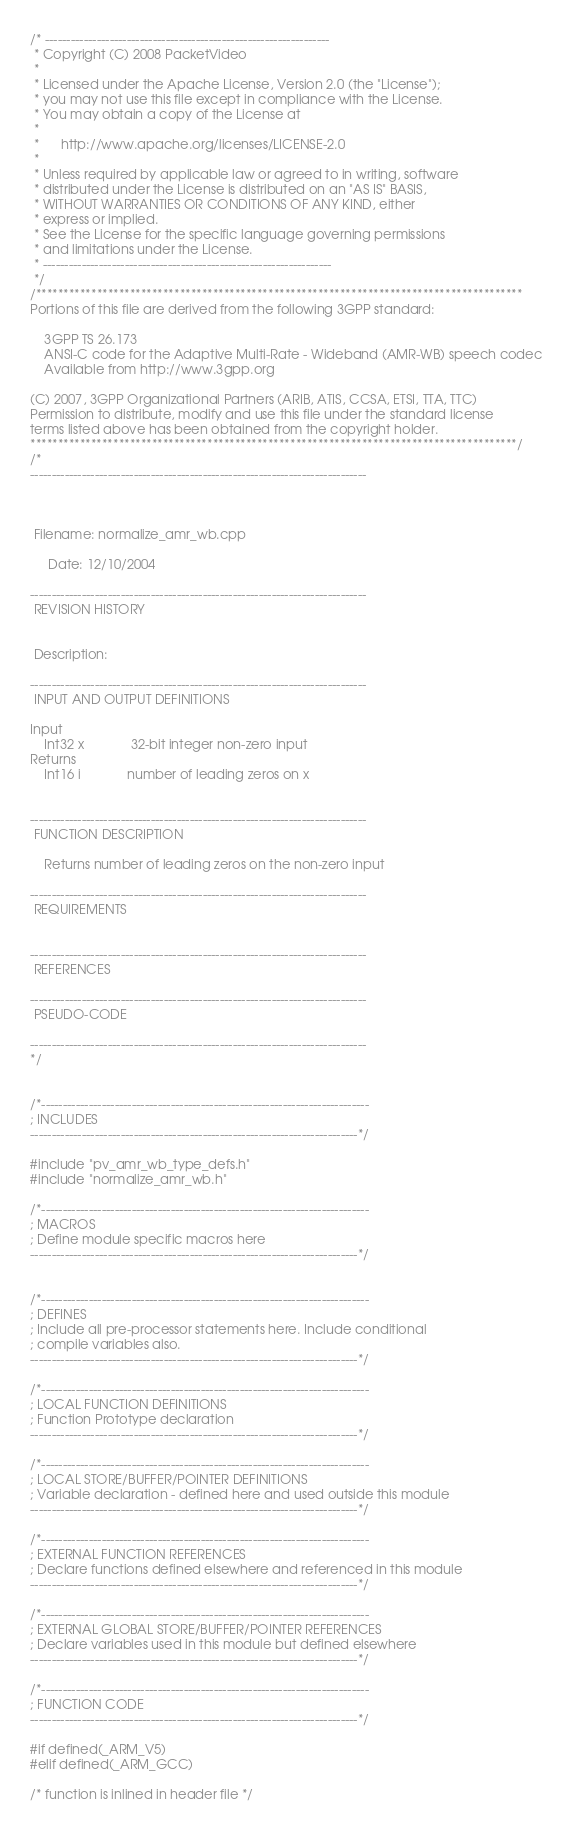Convert code to text. <code><loc_0><loc_0><loc_500><loc_500><_C++_>/* ------------------------------------------------------------------
 * Copyright (C) 2008 PacketVideo
 *
 * Licensed under the Apache License, Version 2.0 (the "License");
 * you may not use this file except in compliance with the License.
 * You may obtain a copy of the License at
 *
 *      http://www.apache.org/licenses/LICENSE-2.0
 *
 * Unless required by applicable law or agreed to in writing, software
 * distributed under the License is distributed on an "AS IS" BASIS,
 * WITHOUT WARRANTIES OR CONDITIONS OF ANY KIND, either
 * express or implied.
 * See the License for the specific language governing permissions
 * and limitations under the License.
 * -------------------------------------------------------------------
 */
/****************************************************************************************
Portions of this file are derived from the following 3GPP standard:

    3GPP TS 26.173
    ANSI-C code for the Adaptive Multi-Rate - Wideband (AMR-WB) speech codec
    Available from http://www.3gpp.org

(C) 2007, 3GPP Organizational Partners (ARIB, ATIS, CCSA, ETSI, TTA, TTC)
Permission to distribute, modify and use this file under the standard license
terms listed above has been obtained from the copyright holder.
****************************************************************************************/
/*
------------------------------------------------------------------------------



 Filename: normalize_amr_wb.cpp

     Date: 12/10/2004

------------------------------------------------------------------------------
 REVISION HISTORY


 Description:

------------------------------------------------------------------------------
 INPUT AND OUTPUT DEFINITIONS

Input
    Int32 x             32-bit integer non-zero input
Returns
    Int16 i             number of leading zeros on x


------------------------------------------------------------------------------
 FUNCTION DESCRIPTION

    Returns number of leading zeros on the non-zero input

------------------------------------------------------------------------------
 REQUIREMENTS


------------------------------------------------------------------------------
 REFERENCES

------------------------------------------------------------------------------
 PSEUDO-CODE

------------------------------------------------------------------------------
*/


/*----------------------------------------------------------------------------
; INCLUDES
----------------------------------------------------------------------------*/

#include "pv_amr_wb_type_defs.h"
#include "normalize_amr_wb.h"

/*----------------------------------------------------------------------------
; MACROS
; Define module specific macros here
----------------------------------------------------------------------------*/


/*----------------------------------------------------------------------------
; DEFINES
; Include all pre-processor statements here. Include conditional
; compile variables also.
----------------------------------------------------------------------------*/

/*----------------------------------------------------------------------------
; LOCAL FUNCTION DEFINITIONS
; Function Prototype declaration
----------------------------------------------------------------------------*/

/*----------------------------------------------------------------------------
; LOCAL STORE/BUFFER/POINTER DEFINITIONS
; Variable declaration - defined here and used outside this module
----------------------------------------------------------------------------*/

/*----------------------------------------------------------------------------
; EXTERNAL FUNCTION REFERENCES
; Declare functions defined elsewhere and referenced in this module
----------------------------------------------------------------------------*/

/*----------------------------------------------------------------------------
; EXTERNAL GLOBAL STORE/BUFFER/POINTER REFERENCES
; Declare variables used in this module but defined elsewhere
----------------------------------------------------------------------------*/

/*----------------------------------------------------------------------------
; FUNCTION CODE
----------------------------------------------------------------------------*/

#if defined(_ARM_V5)
#elif defined(_ARM_GCC)

/* function is inlined in header file */

</code> 